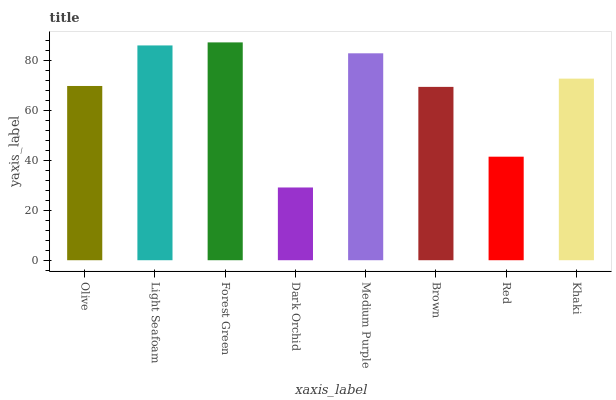Is Dark Orchid the minimum?
Answer yes or no. Yes. Is Forest Green the maximum?
Answer yes or no. Yes. Is Light Seafoam the minimum?
Answer yes or no. No. Is Light Seafoam the maximum?
Answer yes or no. No. Is Light Seafoam greater than Olive?
Answer yes or no. Yes. Is Olive less than Light Seafoam?
Answer yes or no. Yes. Is Olive greater than Light Seafoam?
Answer yes or no. No. Is Light Seafoam less than Olive?
Answer yes or no. No. Is Khaki the high median?
Answer yes or no. Yes. Is Olive the low median?
Answer yes or no. Yes. Is Olive the high median?
Answer yes or no. No. Is Dark Orchid the low median?
Answer yes or no. No. 